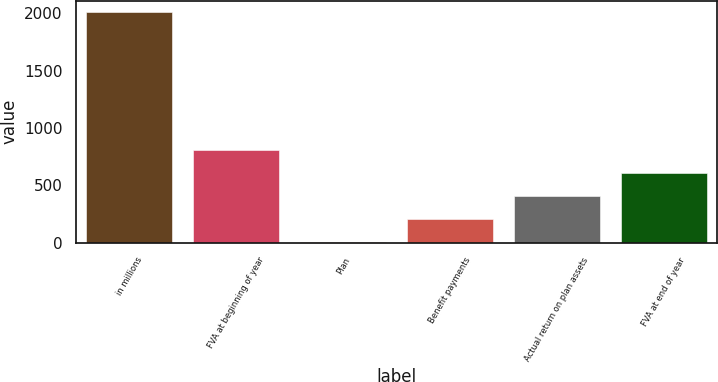Convert chart to OTSL. <chart><loc_0><loc_0><loc_500><loc_500><bar_chart><fcel>in millions<fcel>FVA at beginning of year<fcel>Plan<fcel>Benefit payments<fcel>Actual return on plan assets<fcel>FVA at end of year<nl><fcel>2012<fcel>806<fcel>2<fcel>203<fcel>404<fcel>605<nl></chart> 